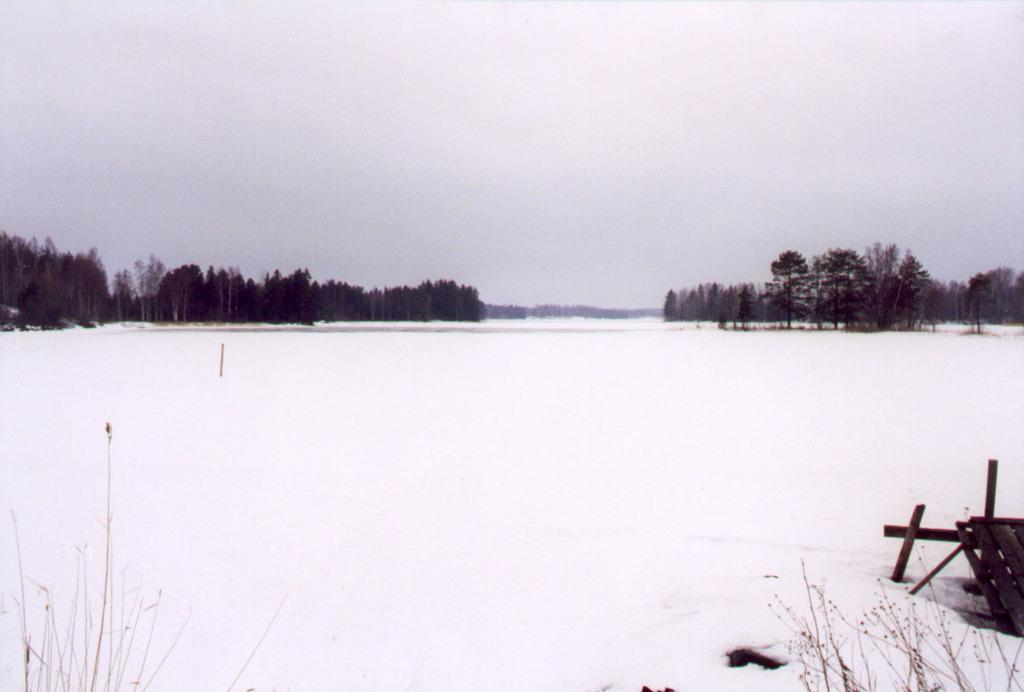What type of environment is depicted in the image? The image shows a snowy environment. What natural features can be seen in the image? There are trees visible in the image. Can you see any caves in the image? There are no caves visible in the image; it shows a snowy environment with trees. What type of friction might be present between the snow and the trees in the image? The image does not provide information about the friction between the snow and the trees, as it only shows the snowy environment and trees. 